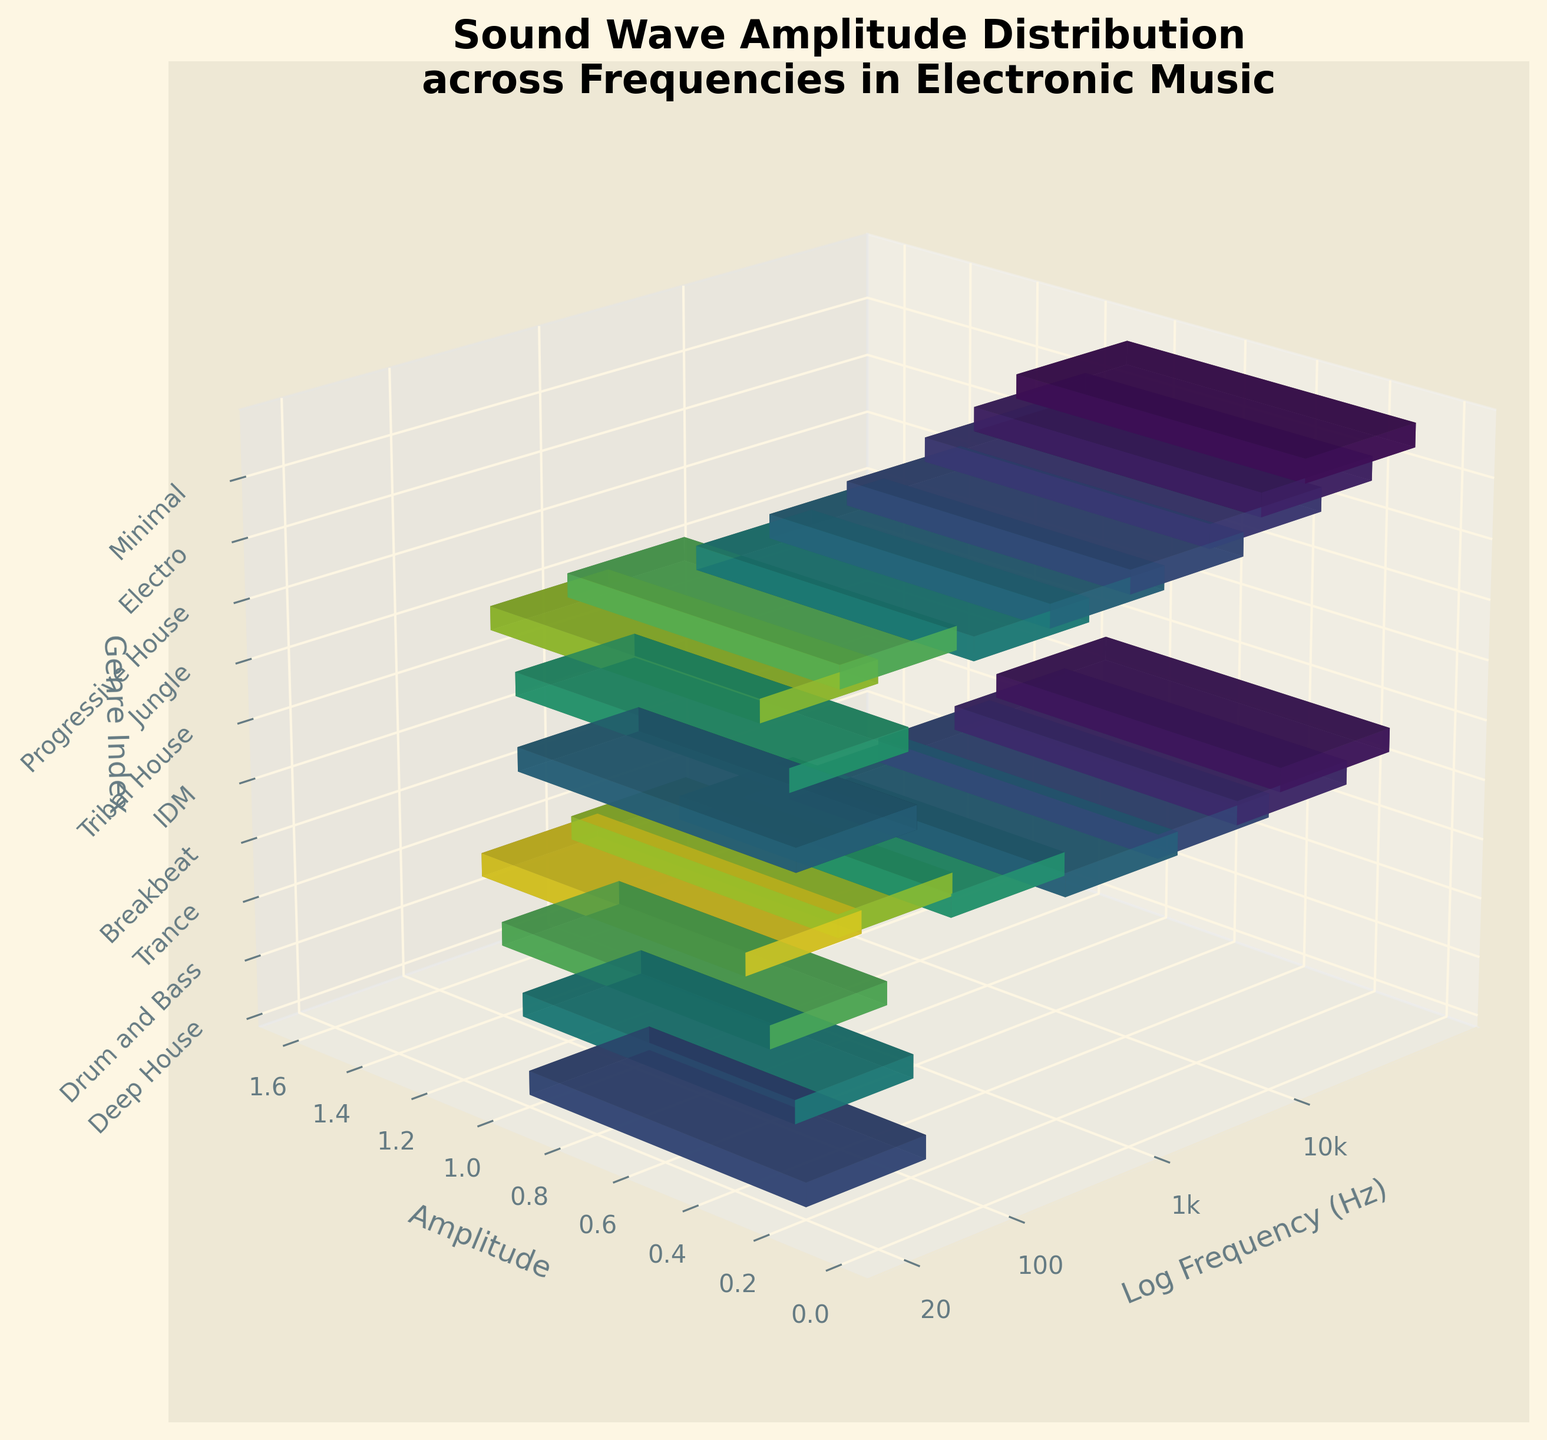What is the title of the figure? The title of the figure is located at the top center and is often written in a font that stands out from the rest of the text. Here, the title reads "Sound Wave Amplitude Distribution across Frequencies in Electronic Music".
Answer: Sound Wave Amplitude Distribution across Frequencies in Electronic Music What genre corresponds to the highest amplitude? To find this, look at the bars that represent the amplitude values. The tallest bar indicates the highest amplitude. The genre index marked on the z-axis shows which genre each bar corresponds to. Here, Deep House has the highest amplitude.
Answer: Deep House Which is the lowest frequency represented in the figure? The x-axis represents the logarithm of the frequency in Hz. The smallest number on this axis is the lowest frequency. The lowest frequency shown is 20 Hz, which is marked as "20".
Answer: 20 Hz Which genre has the lowest amplitude? Look along the y-axis to find the shortest bar, which represents the lowest amplitude. The genre corresponding to this bar is identified on the z-axis. Experimental music has the smallest amplitude.
Answer: Experimental How many frequencies have an amplitude greater than 0.5? Count the bars that have a height above the 0.5 mark on the y-axis. There are four such bars in the figure. The genres linked to these frequencies are Deep House, Tech House, Drum and Bass, and Jungle.
Answer: 4 Which frequency has an amplitude of 0.3? Look for bars that align with a height of 0.3 on the y-axis. Note the corresponding frequencies from the x-axis or refer to the genre index on the z-axis. The frequencies corresponding to an amplitude of 0.3 are 2000 Hz and 1500 Hz.
Answer: 2000 Hz, 1500 Hz Compare the amplitudes of Dubstep and Drum and Bass genres. Which one is higher? Identify the bars corresponding to Dubstep and Drum and Bass using the genre labels on the z-axis. Then, compare the heights of these bars. Drum and Bass has a higher amplitude than Dubstep.
Answer: Drum and Bass What amplitude is observed at 1000 Hz? To find this, locate the frequency of 1000 Hz on the x-axis (converted to log scale) and observe the height of the corresponding bar on the y-axis. The amplitude at 1000 Hz is 0.5.
Answer: 0.5 List the genres in increasing order of their frequencies. Look at the x-axis values (frequencies) and arrange the genres based on these. From lowest to highest in frequency: Deep House, Tribal House, Techno, Tech House, Drum and Bass, Jungle, Dubstep, Hardstyle, Trance, Progressive House, Ambient, Downtempo, Breakbeat, Electro, Garage, Acid House, IDM, Minimal, Glitch, Experimental.
Answer: Deep House, Tribal House, Techno, Tech House, Drum and Bass, Jungle, Dubstep, Hardstyle, Trance, Progressive House, Ambient, Downtempo, Breakbeat, Electro, Garage, Acid House, IDM, Minimal, Glitch, Experimental 